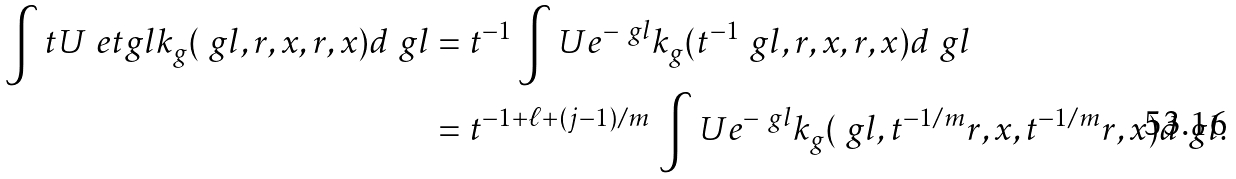<formula> <loc_0><loc_0><loc_500><loc_500>\int t U \ e t g l k _ { g } ( \ g l , r , x , r , x ) d \ g l & = t ^ { - 1 } \int U e ^ { - \ g l } k _ { g } ( t ^ { - 1 } \ g l , r , x , r , x ) d \ g l \\ & = t ^ { - 1 + \ell + ( j - 1 ) / m } \, \int U e ^ { - \ g l } k _ { g } ( \ g l , t ^ { - 1 / m } r , x , t ^ { - 1 / m } r , x ) d \ g l .</formula> 